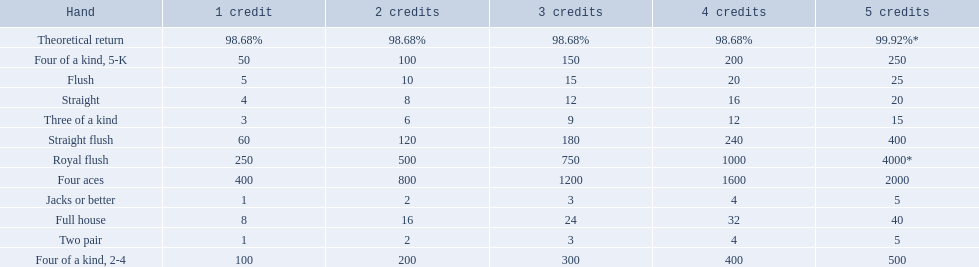Which hand is lower than straight flush? Four aces. Which hand is lower than four aces? Four of a kind, 2-4. Which hand is higher out of straight and flush? Flush. 